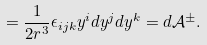Convert formula to latex. <formula><loc_0><loc_0><loc_500><loc_500>= \frac { 1 } { 2 r ^ { 3 } } \epsilon _ { i j k } y ^ { i } d y ^ { j } d y ^ { k } = d \mathcal { A } ^ { \pm } .</formula> 